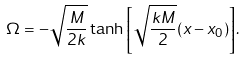<formula> <loc_0><loc_0><loc_500><loc_500>\Omega = - \sqrt { \frac { M } { 2 k } } \tanh { \left [ \sqrt { \frac { k M } { 2 } } ( x - x _ { 0 } ) \right ] } .</formula> 